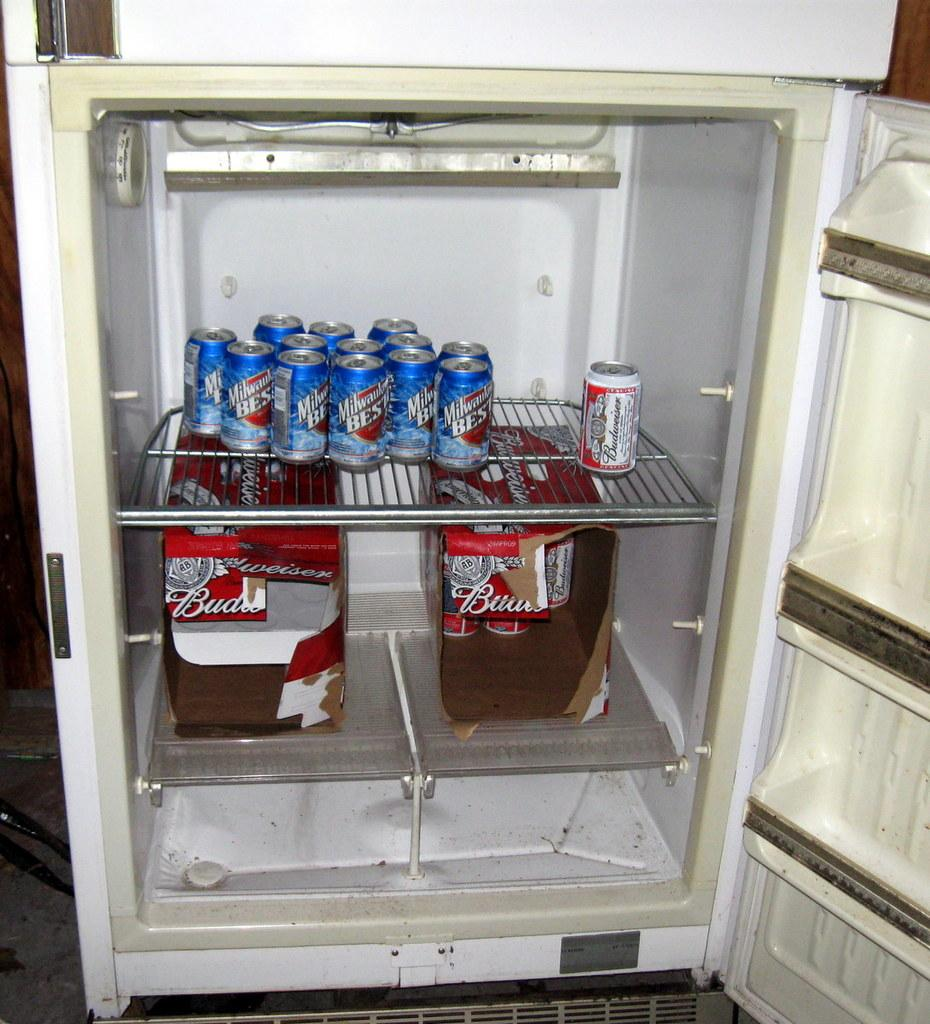<image>
Provide a brief description of the given image. Many cans in a fridge, some of which are Budweiser. 